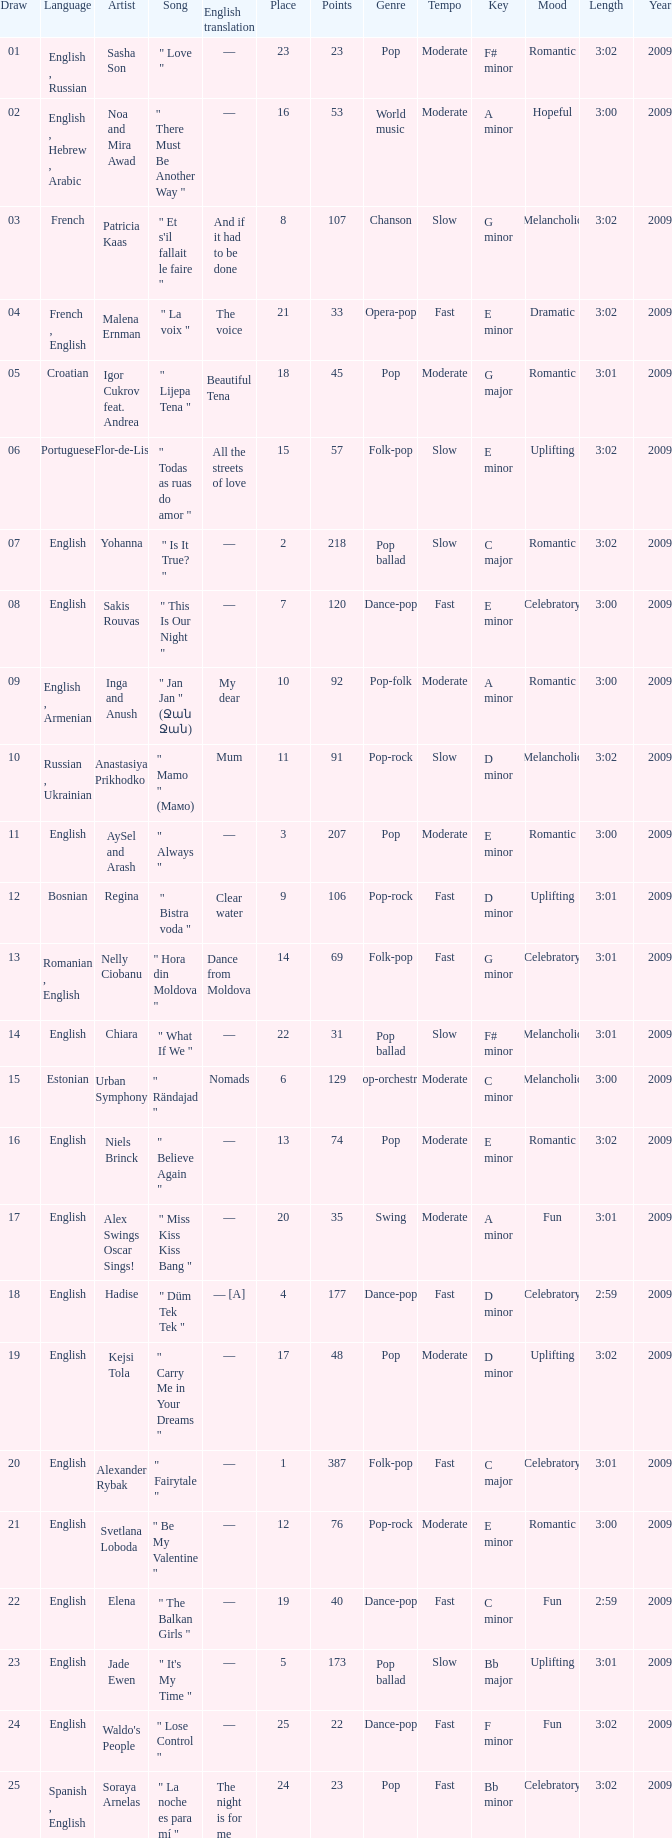What was the english translation for the song by svetlana loboda? —. 